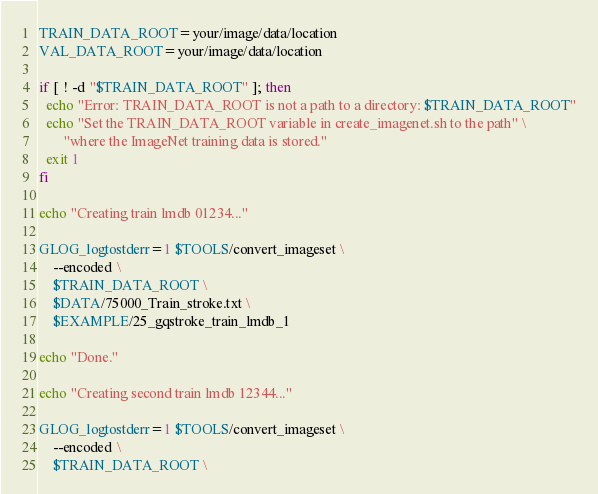Convert code to text. <code><loc_0><loc_0><loc_500><loc_500><_Bash_>TRAIN_DATA_ROOT=your/image/data/location
VAL_DATA_ROOT=your/image/data/location

if [ ! -d "$TRAIN_DATA_ROOT" ]; then
  echo "Error: TRAIN_DATA_ROOT is not a path to a directory: $TRAIN_DATA_ROOT"
  echo "Set the TRAIN_DATA_ROOT variable in create_imagenet.sh to the path" \
       "where the ImageNet training data is stored."
  exit 1
fi

echo "Creating train lmdb 01234..."

GLOG_logtostderr=1 $TOOLS/convert_imageset \
	--encoded \
    $TRAIN_DATA_ROOT \
    $DATA/75000_Train_stroke.txt \
    $EXAMPLE/25_gqstroke_train_lmdb_1

echo "Done."

echo "Creating second train lmdb 12344..."

GLOG_logtostderr=1 $TOOLS/convert_imageset \
	--encoded \
    $TRAIN_DATA_ROOT \</code> 